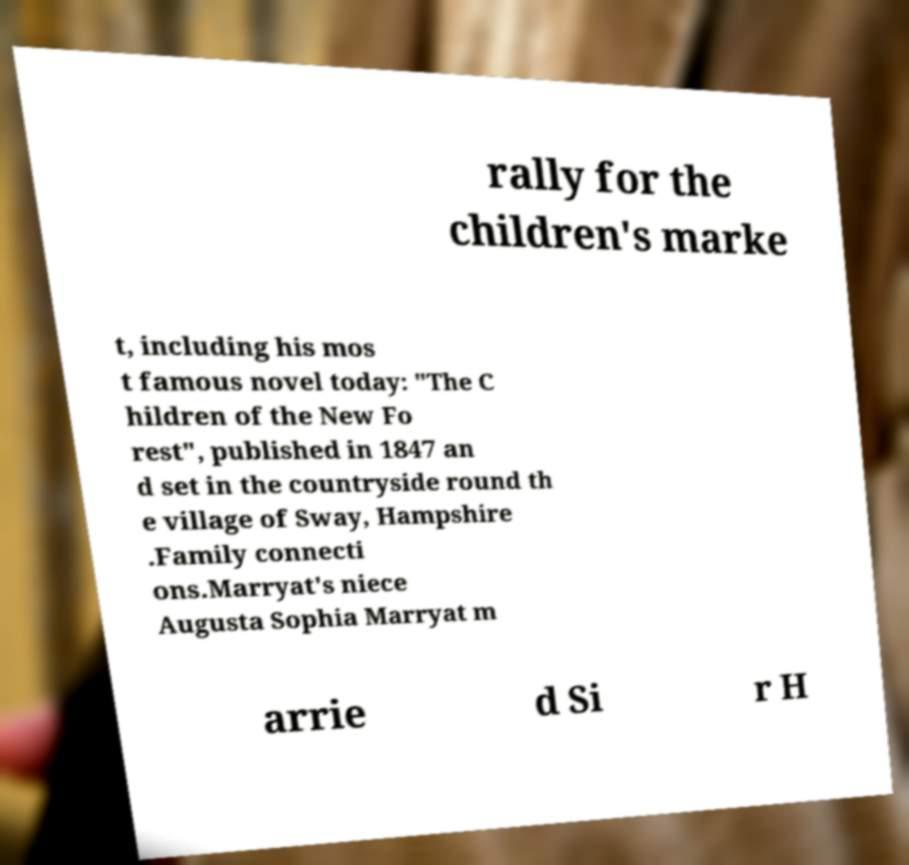Can you read and provide the text displayed in the image?This photo seems to have some interesting text. Can you extract and type it out for me? rally for the children's marke t, including his mos t famous novel today: "The C hildren of the New Fo rest", published in 1847 an d set in the countryside round th e village of Sway, Hampshire .Family connecti ons.Marryat's niece Augusta Sophia Marryat m arrie d Si r H 